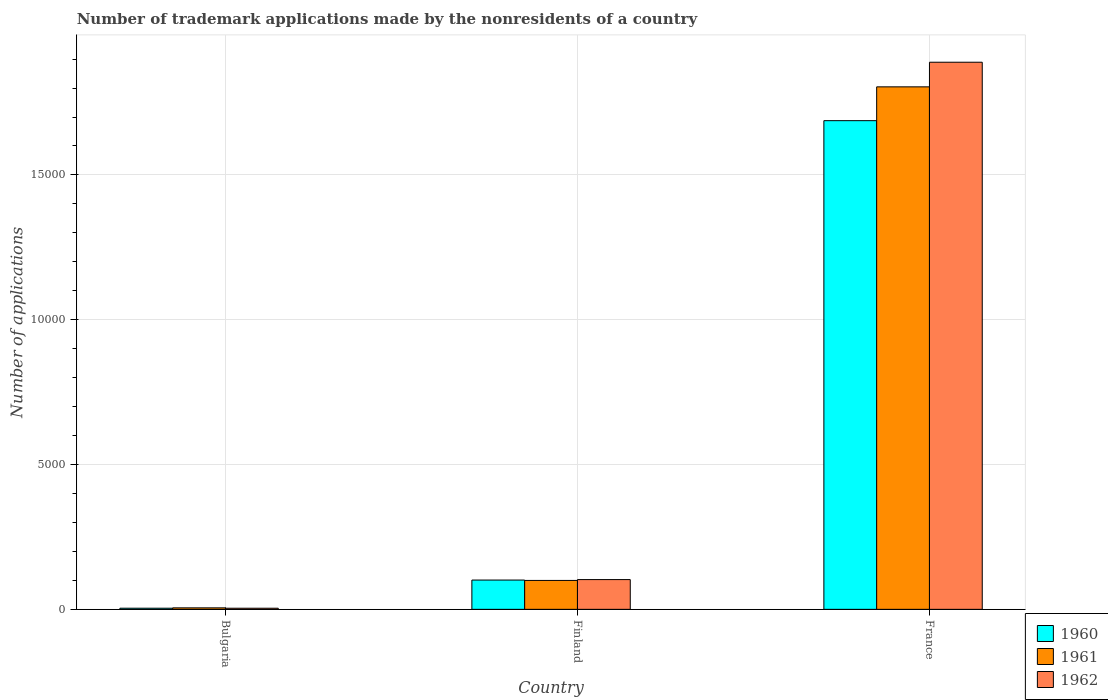How many groups of bars are there?
Keep it short and to the point. 3. Are the number of bars per tick equal to the number of legend labels?
Make the answer very short. Yes. How many bars are there on the 3rd tick from the left?
Provide a succinct answer. 3. How many bars are there on the 2nd tick from the right?
Offer a terse response. 3. What is the number of trademark applications made by the nonresidents in 1961 in France?
Ensure brevity in your answer.  1.80e+04. Across all countries, what is the maximum number of trademark applications made by the nonresidents in 1961?
Your answer should be very brief. 1.80e+04. Across all countries, what is the minimum number of trademark applications made by the nonresidents in 1962?
Provide a succinct answer. 38. In which country was the number of trademark applications made by the nonresidents in 1960 maximum?
Your answer should be compact. France. What is the total number of trademark applications made by the nonresidents in 1962 in the graph?
Make the answer very short. 2.00e+04. What is the difference between the number of trademark applications made by the nonresidents in 1962 in Bulgaria and that in Finland?
Your answer should be compact. -989. What is the difference between the number of trademark applications made by the nonresidents in 1960 in France and the number of trademark applications made by the nonresidents in 1961 in Finland?
Your response must be concise. 1.59e+04. What is the average number of trademark applications made by the nonresidents in 1962 per country?
Provide a short and direct response. 6652.33. What is the difference between the number of trademark applications made by the nonresidents of/in 1962 and number of trademark applications made by the nonresidents of/in 1960 in France?
Ensure brevity in your answer.  2018. In how many countries, is the number of trademark applications made by the nonresidents in 1960 greater than 14000?
Offer a terse response. 1. What is the ratio of the number of trademark applications made by the nonresidents in 1961 in Finland to that in France?
Offer a terse response. 0.06. What is the difference between the highest and the second highest number of trademark applications made by the nonresidents in 1962?
Give a very brief answer. -1.79e+04. What is the difference between the highest and the lowest number of trademark applications made by the nonresidents in 1960?
Keep it short and to the point. 1.68e+04. In how many countries, is the number of trademark applications made by the nonresidents in 1960 greater than the average number of trademark applications made by the nonresidents in 1960 taken over all countries?
Offer a very short reply. 1. What does the 1st bar from the right in France represents?
Make the answer very short. 1962. Is it the case that in every country, the sum of the number of trademark applications made by the nonresidents in 1960 and number of trademark applications made by the nonresidents in 1962 is greater than the number of trademark applications made by the nonresidents in 1961?
Your answer should be very brief. Yes. Are all the bars in the graph horizontal?
Offer a very short reply. No. How many countries are there in the graph?
Keep it short and to the point. 3. What is the difference between two consecutive major ticks on the Y-axis?
Offer a terse response. 5000. Are the values on the major ticks of Y-axis written in scientific E-notation?
Your response must be concise. No. How many legend labels are there?
Offer a very short reply. 3. How are the legend labels stacked?
Provide a short and direct response. Vertical. What is the title of the graph?
Provide a succinct answer. Number of trademark applications made by the nonresidents of a country. What is the label or title of the Y-axis?
Your answer should be very brief. Number of applications. What is the Number of applications in 1961 in Bulgaria?
Offer a terse response. 51. What is the Number of applications in 1960 in Finland?
Give a very brief answer. 1011. What is the Number of applications of 1961 in Finland?
Your response must be concise. 998. What is the Number of applications in 1962 in Finland?
Ensure brevity in your answer.  1027. What is the Number of applications of 1960 in France?
Provide a short and direct response. 1.69e+04. What is the Number of applications of 1961 in France?
Provide a succinct answer. 1.80e+04. What is the Number of applications in 1962 in France?
Provide a succinct answer. 1.89e+04. Across all countries, what is the maximum Number of applications in 1960?
Ensure brevity in your answer.  1.69e+04. Across all countries, what is the maximum Number of applications in 1961?
Keep it short and to the point. 1.80e+04. Across all countries, what is the maximum Number of applications in 1962?
Offer a terse response. 1.89e+04. Across all countries, what is the minimum Number of applications in 1962?
Provide a short and direct response. 38. What is the total Number of applications of 1960 in the graph?
Your response must be concise. 1.79e+04. What is the total Number of applications of 1961 in the graph?
Offer a terse response. 1.91e+04. What is the total Number of applications in 1962 in the graph?
Ensure brevity in your answer.  2.00e+04. What is the difference between the Number of applications of 1960 in Bulgaria and that in Finland?
Offer a very short reply. -972. What is the difference between the Number of applications in 1961 in Bulgaria and that in Finland?
Ensure brevity in your answer.  -947. What is the difference between the Number of applications of 1962 in Bulgaria and that in Finland?
Offer a very short reply. -989. What is the difference between the Number of applications of 1960 in Bulgaria and that in France?
Your answer should be very brief. -1.68e+04. What is the difference between the Number of applications of 1961 in Bulgaria and that in France?
Provide a short and direct response. -1.80e+04. What is the difference between the Number of applications in 1962 in Bulgaria and that in France?
Keep it short and to the point. -1.89e+04. What is the difference between the Number of applications in 1960 in Finland and that in France?
Your response must be concise. -1.59e+04. What is the difference between the Number of applications of 1961 in Finland and that in France?
Your response must be concise. -1.70e+04. What is the difference between the Number of applications of 1962 in Finland and that in France?
Your answer should be very brief. -1.79e+04. What is the difference between the Number of applications in 1960 in Bulgaria and the Number of applications in 1961 in Finland?
Ensure brevity in your answer.  -959. What is the difference between the Number of applications of 1960 in Bulgaria and the Number of applications of 1962 in Finland?
Your response must be concise. -988. What is the difference between the Number of applications of 1961 in Bulgaria and the Number of applications of 1962 in Finland?
Ensure brevity in your answer.  -976. What is the difference between the Number of applications in 1960 in Bulgaria and the Number of applications in 1961 in France?
Provide a short and direct response. -1.80e+04. What is the difference between the Number of applications of 1960 in Bulgaria and the Number of applications of 1962 in France?
Your answer should be compact. -1.89e+04. What is the difference between the Number of applications in 1961 in Bulgaria and the Number of applications in 1962 in France?
Provide a succinct answer. -1.88e+04. What is the difference between the Number of applications of 1960 in Finland and the Number of applications of 1961 in France?
Your answer should be very brief. -1.70e+04. What is the difference between the Number of applications in 1960 in Finland and the Number of applications in 1962 in France?
Your answer should be compact. -1.79e+04. What is the difference between the Number of applications of 1961 in Finland and the Number of applications of 1962 in France?
Give a very brief answer. -1.79e+04. What is the average Number of applications of 1960 per country?
Provide a succinct answer. 5974.67. What is the average Number of applications of 1961 per country?
Provide a succinct answer. 6363.67. What is the average Number of applications of 1962 per country?
Keep it short and to the point. 6652.33. What is the difference between the Number of applications of 1960 and Number of applications of 1962 in Bulgaria?
Your answer should be compact. 1. What is the difference between the Number of applications in 1961 and Number of applications in 1962 in Bulgaria?
Your response must be concise. 13. What is the difference between the Number of applications of 1961 and Number of applications of 1962 in Finland?
Ensure brevity in your answer.  -29. What is the difference between the Number of applications in 1960 and Number of applications in 1961 in France?
Provide a short and direct response. -1168. What is the difference between the Number of applications of 1960 and Number of applications of 1962 in France?
Ensure brevity in your answer.  -2018. What is the difference between the Number of applications in 1961 and Number of applications in 1962 in France?
Your answer should be very brief. -850. What is the ratio of the Number of applications of 1960 in Bulgaria to that in Finland?
Your answer should be compact. 0.04. What is the ratio of the Number of applications in 1961 in Bulgaria to that in Finland?
Make the answer very short. 0.05. What is the ratio of the Number of applications in 1962 in Bulgaria to that in Finland?
Offer a terse response. 0.04. What is the ratio of the Number of applications in 1960 in Bulgaria to that in France?
Offer a terse response. 0. What is the ratio of the Number of applications in 1961 in Bulgaria to that in France?
Provide a short and direct response. 0. What is the ratio of the Number of applications in 1962 in Bulgaria to that in France?
Ensure brevity in your answer.  0. What is the ratio of the Number of applications in 1960 in Finland to that in France?
Your answer should be compact. 0.06. What is the ratio of the Number of applications of 1961 in Finland to that in France?
Offer a terse response. 0.06. What is the ratio of the Number of applications in 1962 in Finland to that in France?
Make the answer very short. 0.05. What is the difference between the highest and the second highest Number of applications of 1960?
Give a very brief answer. 1.59e+04. What is the difference between the highest and the second highest Number of applications in 1961?
Your answer should be very brief. 1.70e+04. What is the difference between the highest and the second highest Number of applications in 1962?
Offer a terse response. 1.79e+04. What is the difference between the highest and the lowest Number of applications in 1960?
Make the answer very short. 1.68e+04. What is the difference between the highest and the lowest Number of applications of 1961?
Your answer should be compact. 1.80e+04. What is the difference between the highest and the lowest Number of applications of 1962?
Keep it short and to the point. 1.89e+04. 